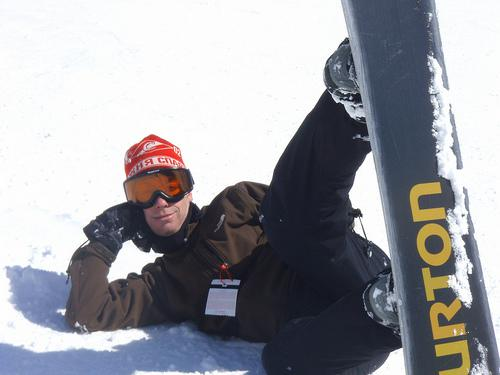Question: why is there a shadow?
Choices:
A. The camera light.
B. The sun is shining on the people.
C. The lighting in the building.
D. It is sunny.
Answer with the letter. Answer: D Question: what color is the man's hat?
Choices:
A. Red.
B. White.
C. Black.
D. Yellow.
Answer with the letter. Answer: A Question: how is the man positioned?
Choices:
A. He is laying down.
B. He is standing.
C. He is stooping.
D. He is bent over.
Answer with the letter. Answer: A Question: what is at his feet?
Choices:
A. A guitar.
B. A cat.
C. A snowboard.
D. A suitcase.
Answer with the letter. Answer: C Question: when was the photo taken?
Choices:
A. Night time.
B. Daytime.
C. During a meal.
D. In the morning.
Answer with the letter. Answer: B 